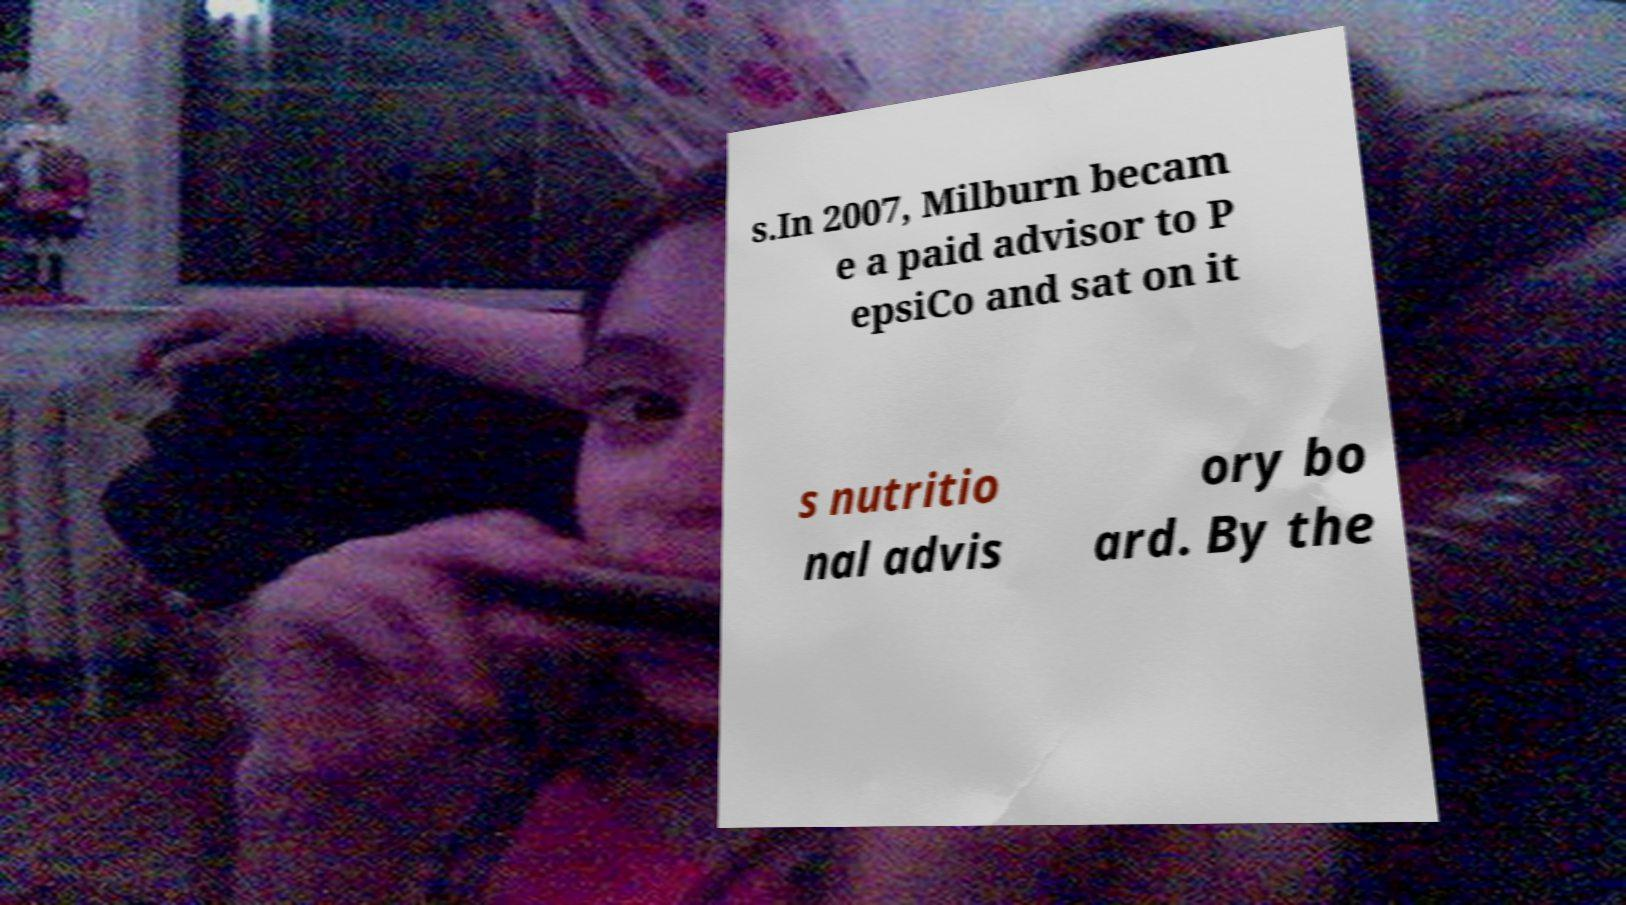There's text embedded in this image that I need extracted. Can you transcribe it verbatim? s.In 2007, Milburn becam e a paid advisor to P epsiCo and sat on it s nutritio nal advis ory bo ard. By the 